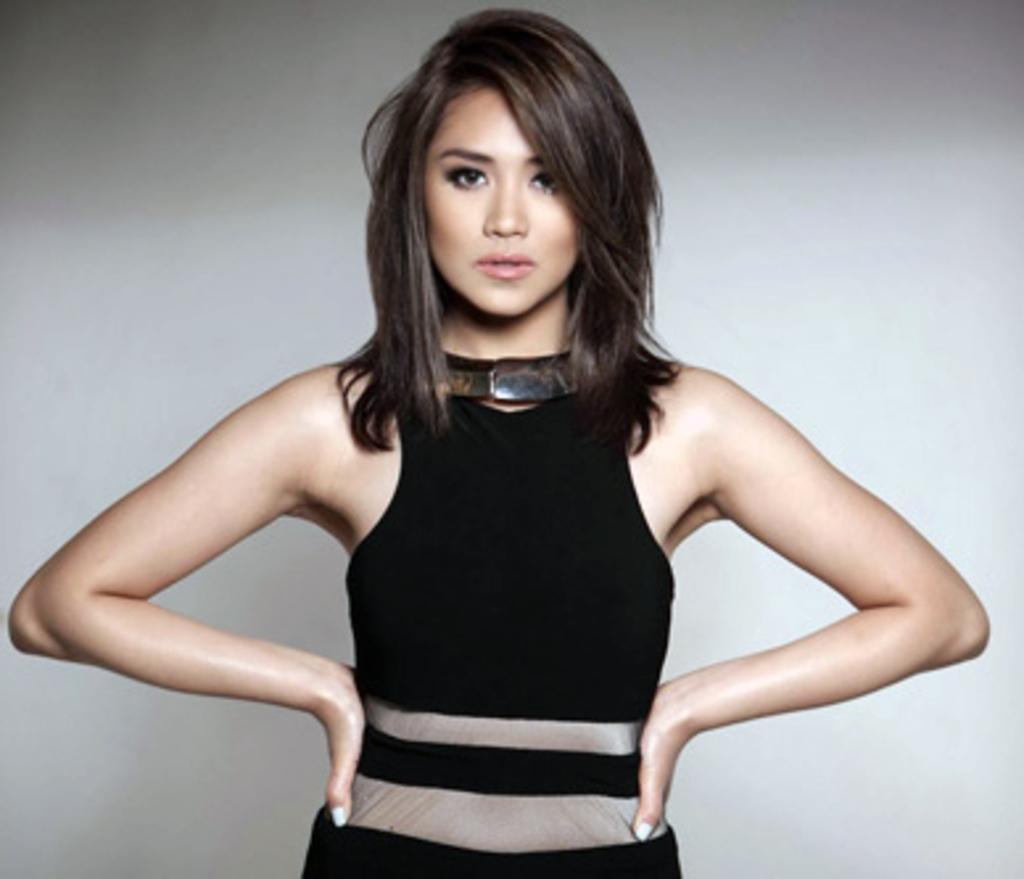In one or two sentences, can you explain what this image depicts? In this picture there is a woman standing wearing a black dress. In the background it is well. 